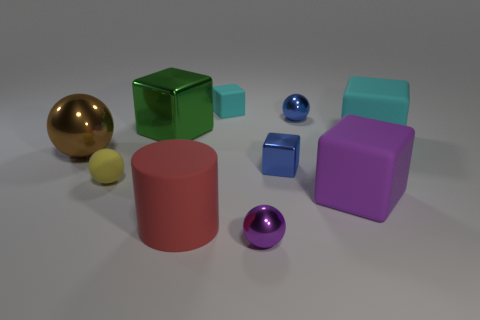Subtract all large green cubes. How many cubes are left? 4 Subtract all yellow spheres. How many spheres are left? 3 Add 1 red things. How many red things are left? 2 Add 7 rubber cylinders. How many rubber cylinders exist? 8 Subtract 1 purple cubes. How many objects are left? 9 Subtract all balls. How many objects are left? 6 Subtract 1 cylinders. How many cylinders are left? 0 Subtract all red cubes. Subtract all brown balls. How many cubes are left? 5 Subtract all green blocks. How many blue spheres are left? 1 Subtract all big cyan matte objects. Subtract all green cubes. How many objects are left? 8 